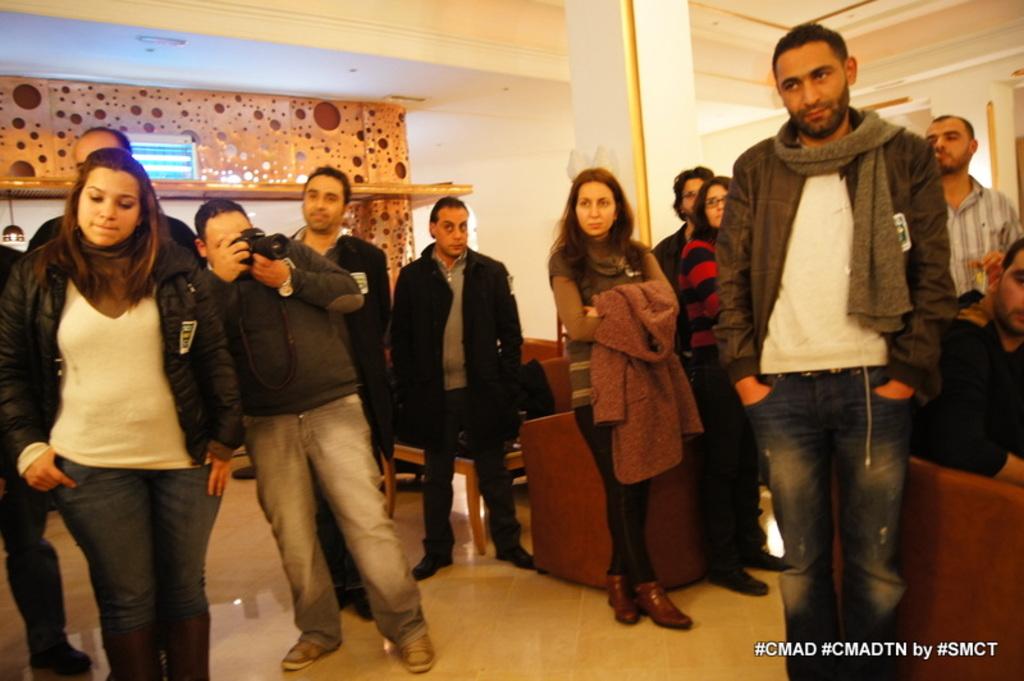What hashtags are on this picture?
Provide a succinct answer. #cmad #cmadtn #smct. 